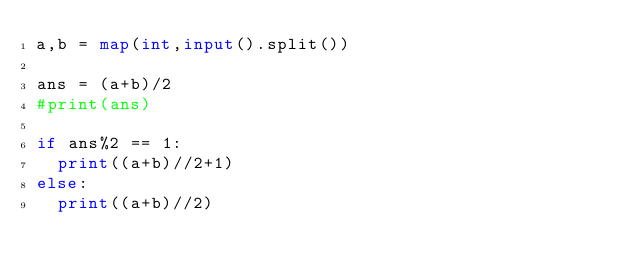<code> <loc_0><loc_0><loc_500><loc_500><_Python_>a,b = map(int,input().split())

ans = (a+b)/2
#print(ans)

if ans%2 == 1:
  print((a+b)//2+1)
else:
  print((a+b)//2)</code> 